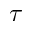<formula> <loc_0><loc_0><loc_500><loc_500>\tau</formula> 